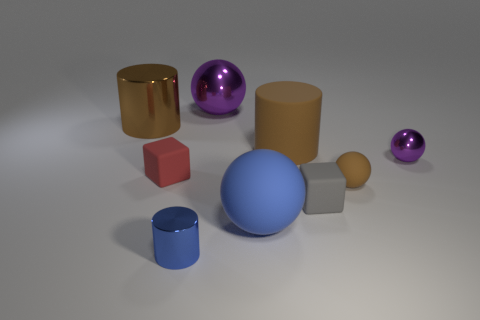What color is the small shiny thing behind the small metallic cylinder?
Keep it short and to the point. Purple. There is a object that is the same color as the big shiny sphere; what shape is it?
Your answer should be very brief. Sphere. There is a small red thing that is on the left side of the gray matte object; what is its shape?
Keep it short and to the point. Cube. How many gray objects are either matte balls or big matte cylinders?
Your response must be concise. 0. Is the material of the big blue object the same as the gray cube?
Your response must be concise. Yes. There is a brown metallic object; how many big spheres are in front of it?
Your answer should be very brief. 1. What is the thing that is both in front of the brown matte cylinder and left of the blue cylinder made of?
Your response must be concise. Rubber. What number of blocks are either large blue objects or tiny blue shiny objects?
Provide a short and direct response. 0. There is another brown object that is the same shape as the brown shiny object; what material is it?
Provide a short and direct response. Rubber. The brown cylinder that is the same material as the small blue cylinder is what size?
Make the answer very short. Large. 